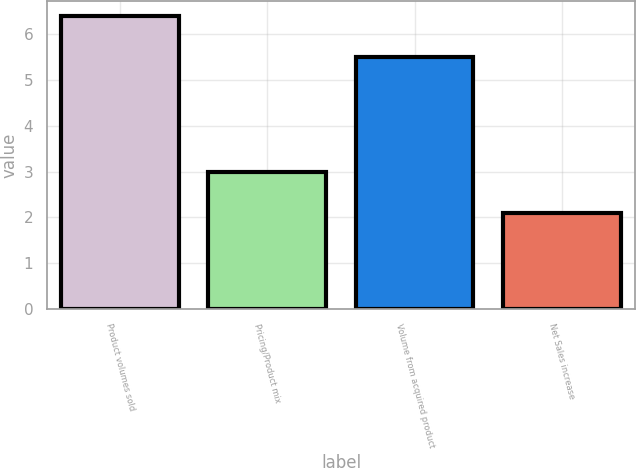<chart> <loc_0><loc_0><loc_500><loc_500><bar_chart><fcel>Product volumes sold<fcel>Pricing/Product mix<fcel>Volume from acquired product<fcel>Net Sales increase<nl><fcel>6.4<fcel>3<fcel>5.5<fcel>2.1<nl></chart> 